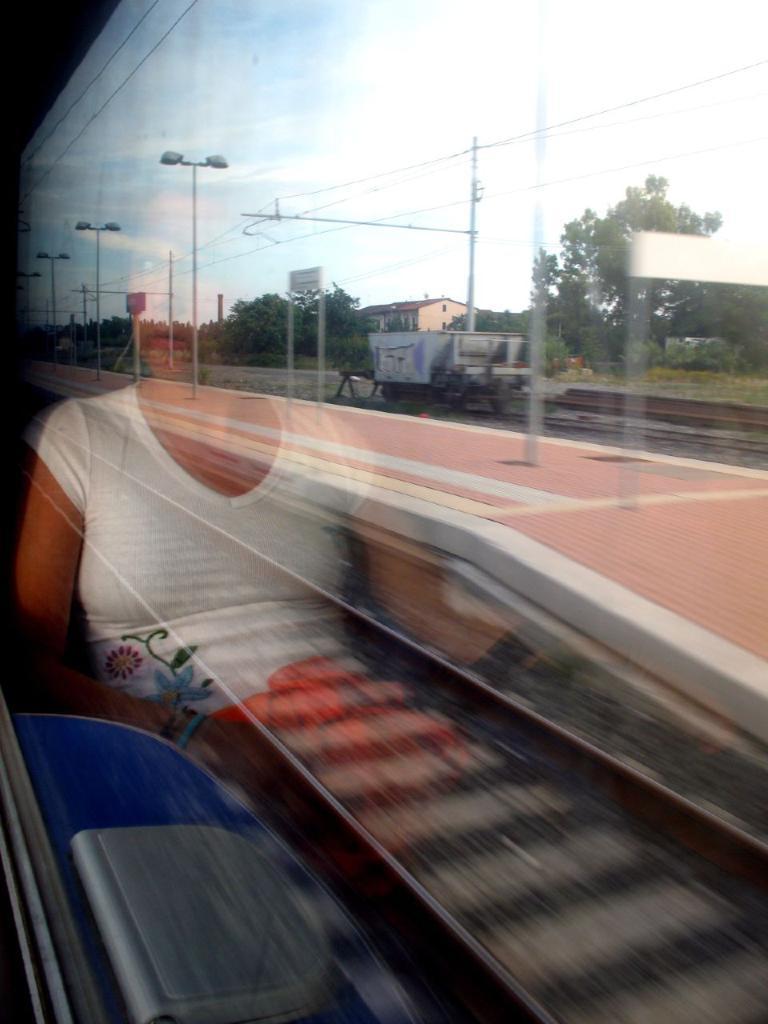In one or two sentences, can you explain what this image depicts? There is a glass which has a person on it and there is a railway track,platform,trees and a building in the background. 